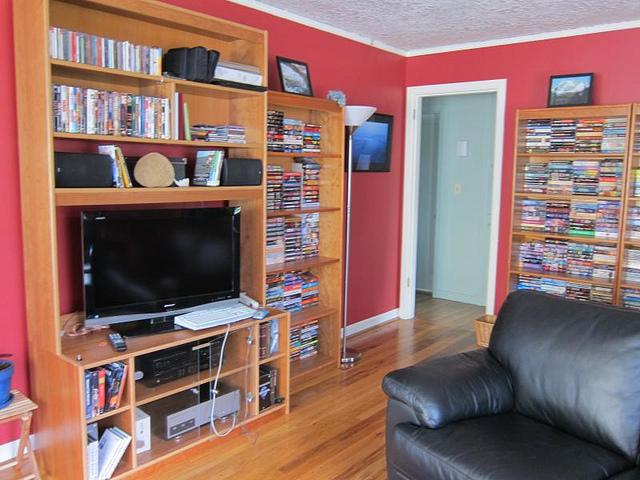Does the person living here enjoy movies?
Write a very short answer. Yes. Would this room be used primarily for sleeping?
Answer briefly. No. What materials shown came from living organisms?
Keep it brief. 0. Is the tv on?
Answer briefly. No. 